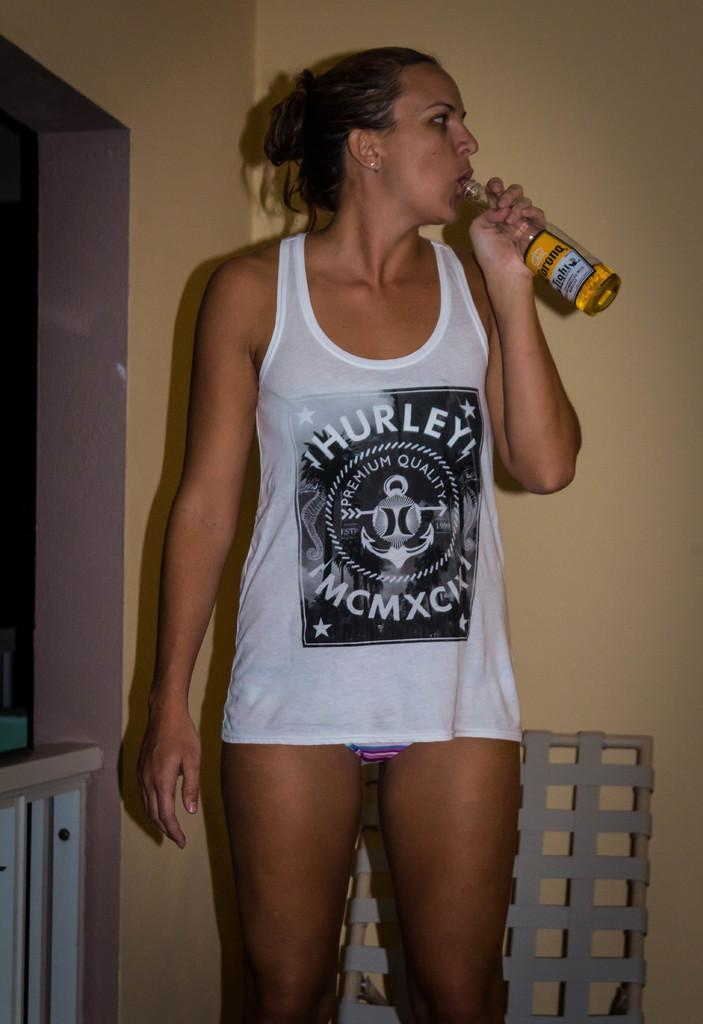Who is present in the image? There is a woman in the image. What is the woman doing in the image? The woman is standing in the image. What is the woman holding in the image? The woman is holding a beer bottle in the image. What can be seen in the background of the image? There is a cabinet, an object, and a wall in the background of the image. What type of turkey can be seen in the image? There is no turkey present in the image. What kind of arch is visible in the background of the image? There is: There is no arch visible in the image. 